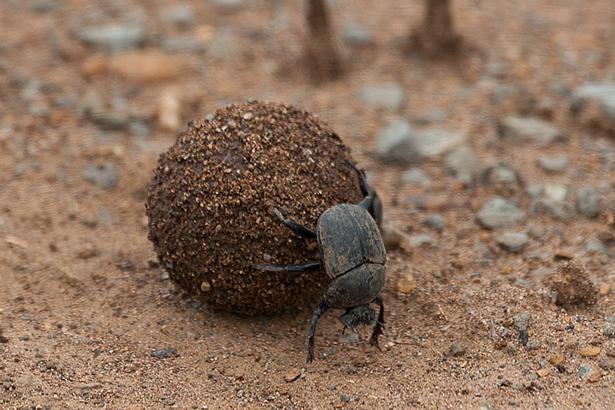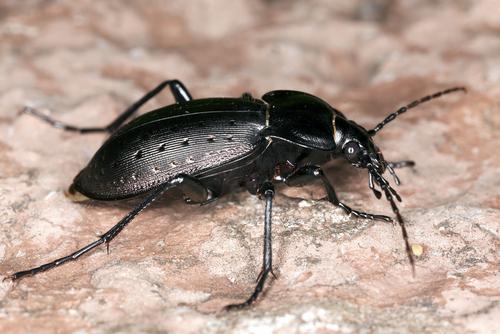The first image is the image on the left, the second image is the image on the right. Assess this claim about the two images: "There are at most three beetles.". Correct or not? Answer yes or no. Yes. The first image is the image on the left, the second image is the image on the right. Assess this claim about the two images: "Each image has at least 2 dung beetles interacting with a piece of dung.". Correct or not? Answer yes or no. No. 